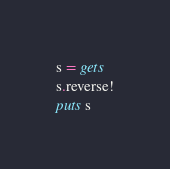<code> <loc_0><loc_0><loc_500><loc_500><_Ruby_>s = gets
s.reverse!
puts s</code> 